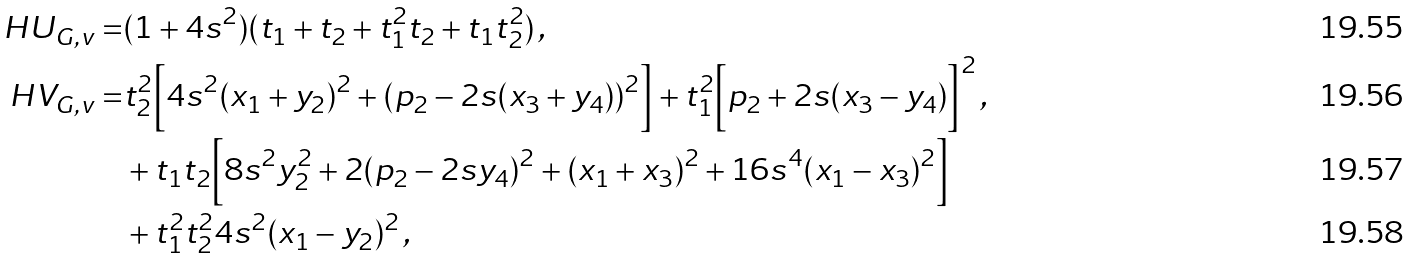Convert formula to latex. <formula><loc_0><loc_0><loc_500><loc_500>H U _ { G , v } = & ( 1 + 4 s ^ { 2 } ) ( t _ { 1 } + t _ { 2 } + t _ { 1 } ^ { 2 } t _ { 2 } + t _ { 1 } t _ { 2 } ^ { 2 } ) \, , \\ H V _ { G , v } = & t _ { 2 } ^ { 2 } \Big { [ } 4 s ^ { 2 } ( x _ { 1 } + y _ { 2 } ) ^ { 2 } + ( p _ { 2 } - 2 s ( x _ { 3 } + y _ { 4 } ) ) ^ { 2 } \Big { ] } + t _ { 1 } ^ { 2 } \Big { [ } p _ { 2 } + 2 s ( x _ { 3 } - y _ { 4 } ) \Big { ] } ^ { 2 } \, , \\ & + t _ { 1 } t _ { 2 } \Big { [ } 8 s ^ { 2 } y _ { 2 } ^ { 2 } + 2 ( p _ { 2 } - 2 s y _ { 4 } ) ^ { 2 } + ( x _ { 1 } + x _ { 3 } ) ^ { 2 } + 1 6 s ^ { 4 } ( x _ { 1 } - x _ { 3 } ) ^ { 2 } \Big { ] } \\ & + t _ { 1 } ^ { 2 } t _ { 2 } ^ { 2 } 4 s ^ { 2 } ( x _ { 1 } - y _ { 2 } ) ^ { 2 } \, ,</formula> 